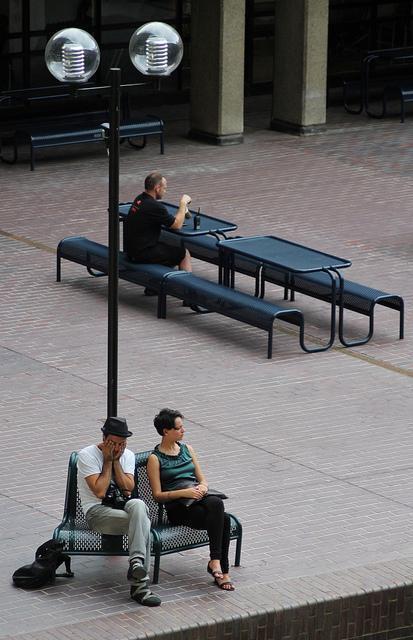What is the man at the table doing?
From the following set of four choices, select the accurate answer to respond to the question.
Options: Drinking, jumping, sleeping, standing. Drinking. 